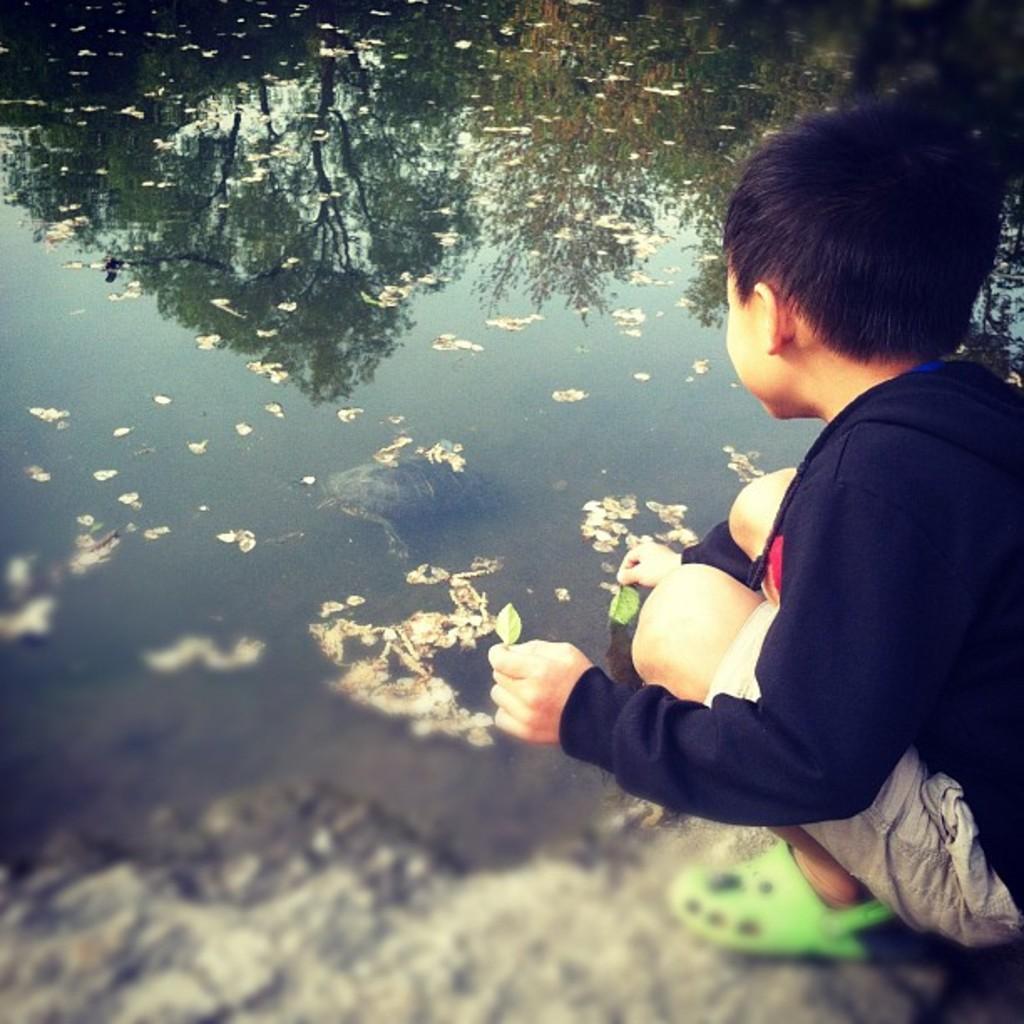Can you describe this image briefly? In this image I can see a child wearing black and white dress and green colored footwear is sitting and holding few leaves in his hands. In the background I can see the water and on the water I can see the reflection of few trees and the sky. 